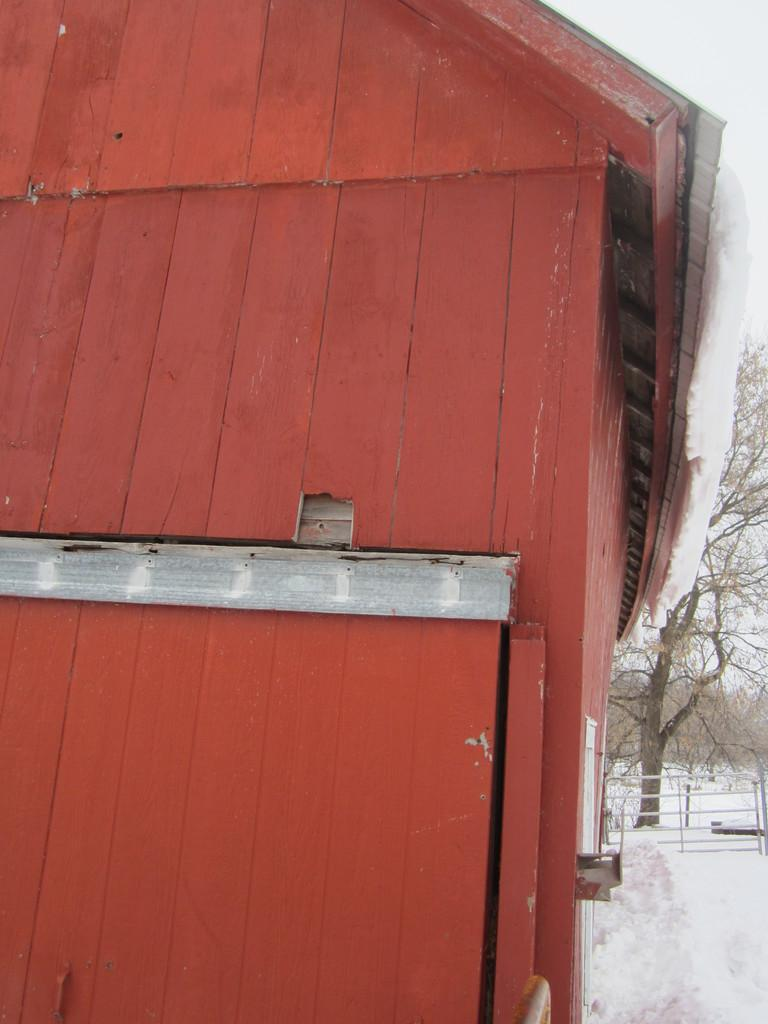What type of structure is present in the image? There is a house with a roof in the image. What can be seen surrounding the house? There is a fence in the image. What is the weather like in the image? There is snow visible in the image, indicating a cold or wintry environment. What type of vegetation is present in the image? There is a group of trees in the image. What is visible above the house and trees? The sky is visible in the image. Where is the pocket located in the image? There is no pocket present in the image. What type of joke is being told by the trees in the image? There are no jokes or any form of communication being depicted by the trees in the image. 